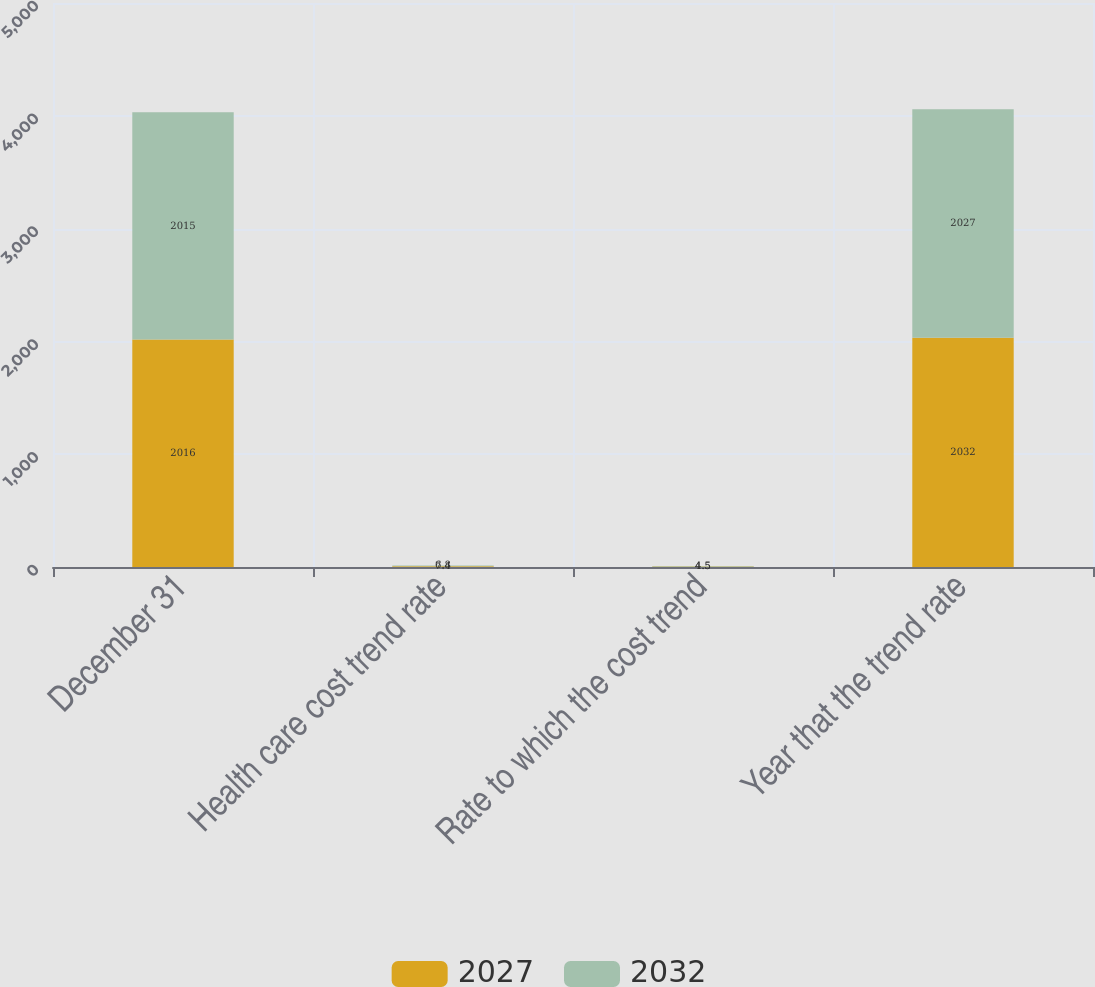<chart> <loc_0><loc_0><loc_500><loc_500><stacked_bar_chart><ecel><fcel>December 31<fcel>Health care cost trend rate<fcel>Rate to which the cost trend<fcel>Year that the trend rate<nl><fcel>2027<fcel>2016<fcel>7.4<fcel>4.5<fcel>2032<nl><fcel>2032<fcel>2015<fcel>6.8<fcel>4.5<fcel>2027<nl></chart> 